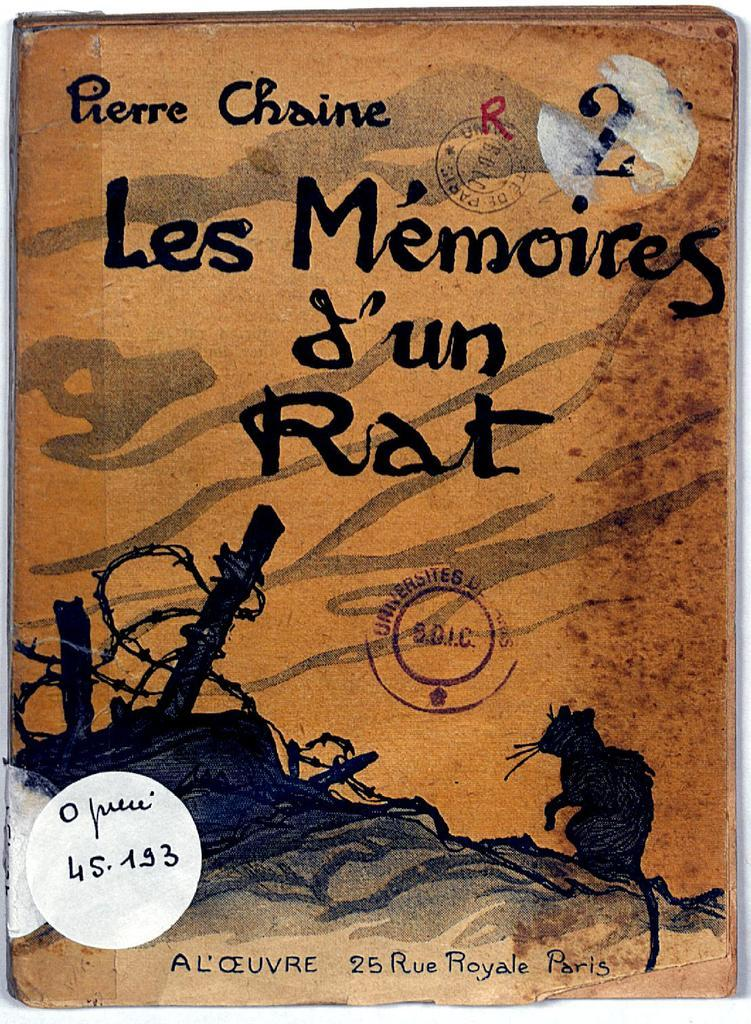<image>
Give a short and clear explanation of the subsequent image. A of book written by Pierre Chaine calle Les Memories. 